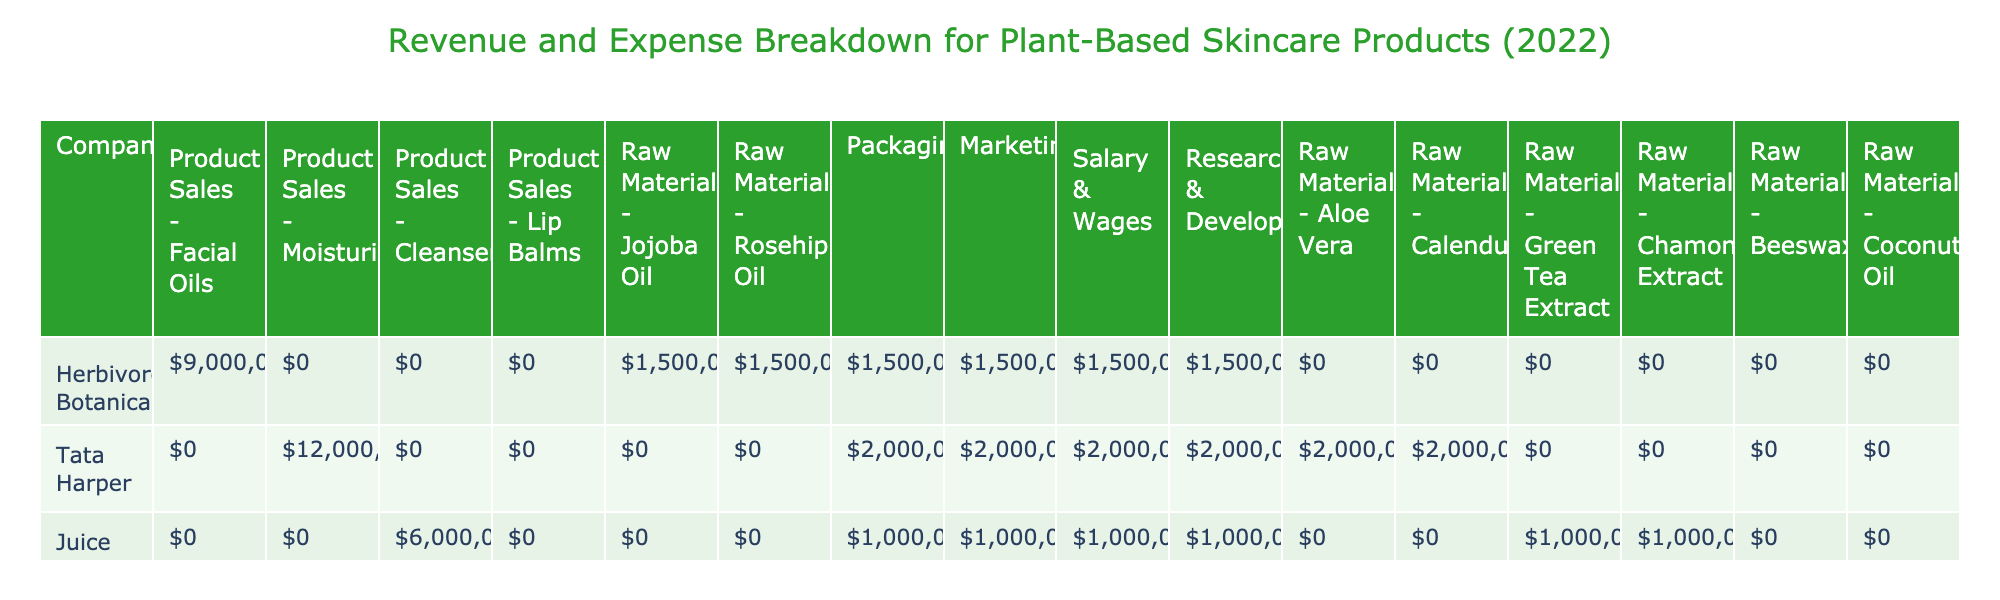What is the total revenue from product sales for Herbivore Botanicals? The revenue for Herbivore Botanicals from product sales is listed as $1,500,000 for Facial Oils. There are no other revenue streams mentioned for this company.
Answer: $1,500,000 What was the total expense for Research & Development across all companies? The expenses for Research & Development are as follows: Herbivore Botanicals $250,000, Tata Harper $300,000, Juice Beauty $180,000, and Burt's Bees $280,000. Summing these amounts gives $250,000 + $300,000 + $180,000 + $280,000 = $1,010,000.
Answer: $1,010,000 Did Juice Beauty have higher expenses in Marketing or Salary & Wages? Juice Beauty's Marketing expense is $180,000, and Salary & Wages expense is $320,000. Since $320,000 is greater than $180,000, the answer is Yes.
Answer: Yes What is the difference in total revenues between Tata Harper and Juice Beauty? Tata Harper's revenue is $2,000,000 from Moisturizers, and Juice Beauty's revenue is $1,000,000 from Cleansers. The difference is $2,000,000 - $1,000,000 = $1,000,000.
Answer: $1,000,000 Which company spent the most on Packaging? The packaging expenses are: Herbivore Botanicals $100,000, Tata Harper $150,000, Juice Beauty $70,000, and Burt's Bees $120,000. The highest expense is Tata Harper with $150,000.
Answer: Tata Harper 